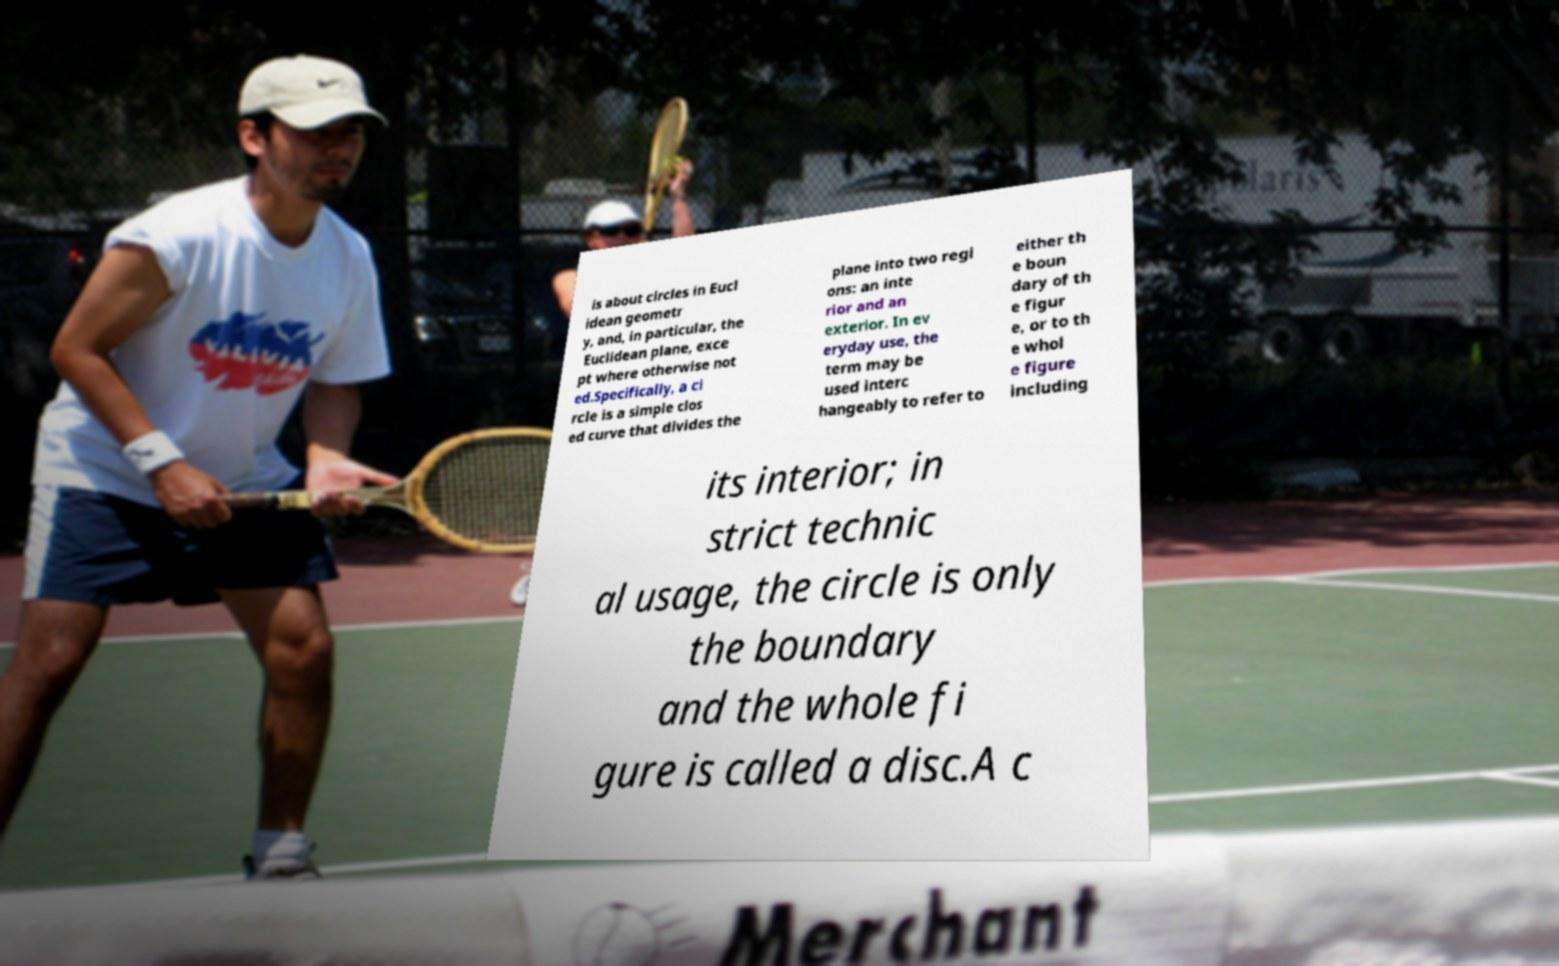What messages or text are displayed in this image? I need them in a readable, typed format. is about circles in Eucl idean geometr y, and, in particular, the Euclidean plane, exce pt where otherwise not ed.Specifically, a ci rcle is a simple clos ed curve that divides the plane into two regi ons: an inte rior and an exterior. In ev eryday use, the term may be used interc hangeably to refer to either th e boun dary of th e figur e, or to th e whol e figure including its interior; in strict technic al usage, the circle is only the boundary and the whole fi gure is called a disc.A c 